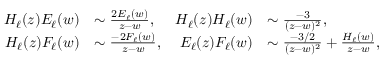Convert formula to latex. <formula><loc_0><loc_0><loc_500><loc_500>\begin{array} { r l r l } { H _ { \ell } ( z ) E _ { \ell } ( w ) } & { \sim \frac { 2 E _ { \ell } ( w ) } { z - w } , } & { H _ { \ell } ( z ) H _ { \ell } ( w ) } & { \sim \frac { - 3 } { ( z - w ) ^ { 2 } } , } \\ { H _ { \ell } ( z ) F _ { \ell } ( w ) } & { \sim \frac { - 2 F _ { \ell } ( w ) } { z - w } , } & { E _ { \ell } ( z ) F _ { \ell } ( w ) } & { \sim \frac { - 3 / 2 } { ( z - w ) ^ { 2 } } + \frac { H _ { \ell } ( w ) } { z - w } , } \end{array}</formula> 